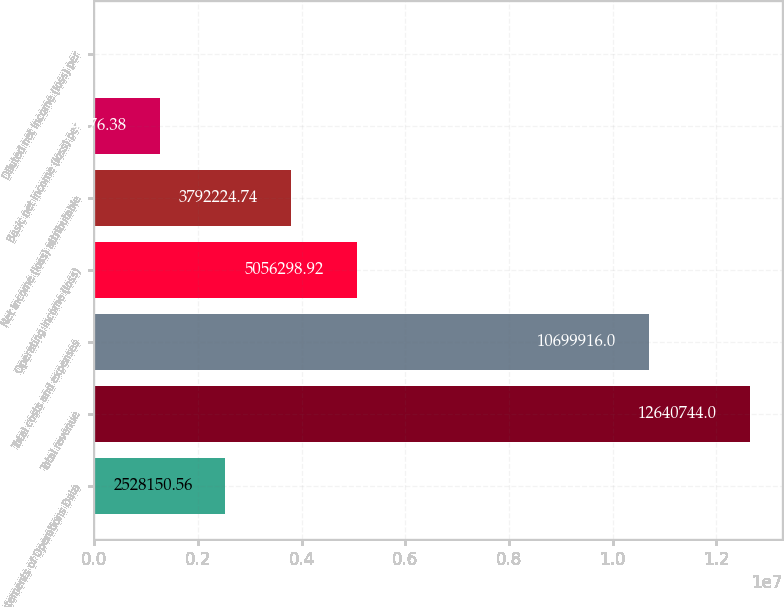Convert chart to OTSL. <chart><loc_0><loc_0><loc_500><loc_500><bar_chart><fcel>Statements of Operations Data<fcel>Total revenue<fcel>Total costs and expenses<fcel>Operating income (loss)<fcel>Net income (loss) attributable<fcel>Basic net income (loss) per<fcel>Diluted net income (loss) per<nl><fcel>2.52815e+06<fcel>1.26407e+07<fcel>1.06999e+07<fcel>5.0563e+06<fcel>3.79222e+06<fcel>1.26408e+06<fcel>2.2<nl></chart> 